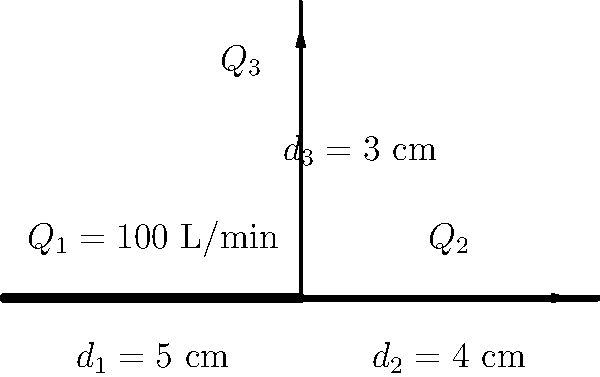In the pipe network shown, water flows from left to right in the main pipe and splits at the junction. Given that the flow rate in the first segment is $Q_1 = 100$ L/min, and using the continuity equation, calculate the flow rate $Q_3$ in the vertical pipe segment with diameter $d_3 = 3$ cm. To solve this problem, we'll use the continuity equation and the given information:

1) The continuity equation states that the total flow rate entering a junction must equal the total flow rate leaving the junction. In this case:
   $Q_1 = Q_2 + Q_3$

2) We're given that $Q_1 = 100$ L/min.

3) The continuity equation also states that for incompressible flow, the product of velocity and cross-sectional area remains constant. This means:
   $v_1A_1 = v_2A_2 = v_3A_3$

4) The cross-sectional area is proportional to the square of the diameter. So we can write:
   $Q_1d_1^2 = Q_2d_2^2 = Q_3d_3^2$

5) From this, we can express $Q_2$ and $Q_3$ in terms of $Q_1$:
   $Q_2 = Q_1 \cdot (\frac{d_2}{d_1})^2 = 100 \cdot (\frac{4}{5})^2 = 64$ L/min

6) Now we can find $Q_3$ using the continuity equation from step 1:
   $Q_3 = Q_1 - Q_2 = 100 - 64 = 36$ L/min

7) We can verify this using the equation from step 4:
   $Q_3 = Q_1 \cdot (\frac{d_3}{d_1})^2 = 100 \cdot (\frac{3}{5})^2 = 36$ L/min

Therefore, the flow rate in the vertical pipe segment is 36 L/min.
Answer: 36 L/min 